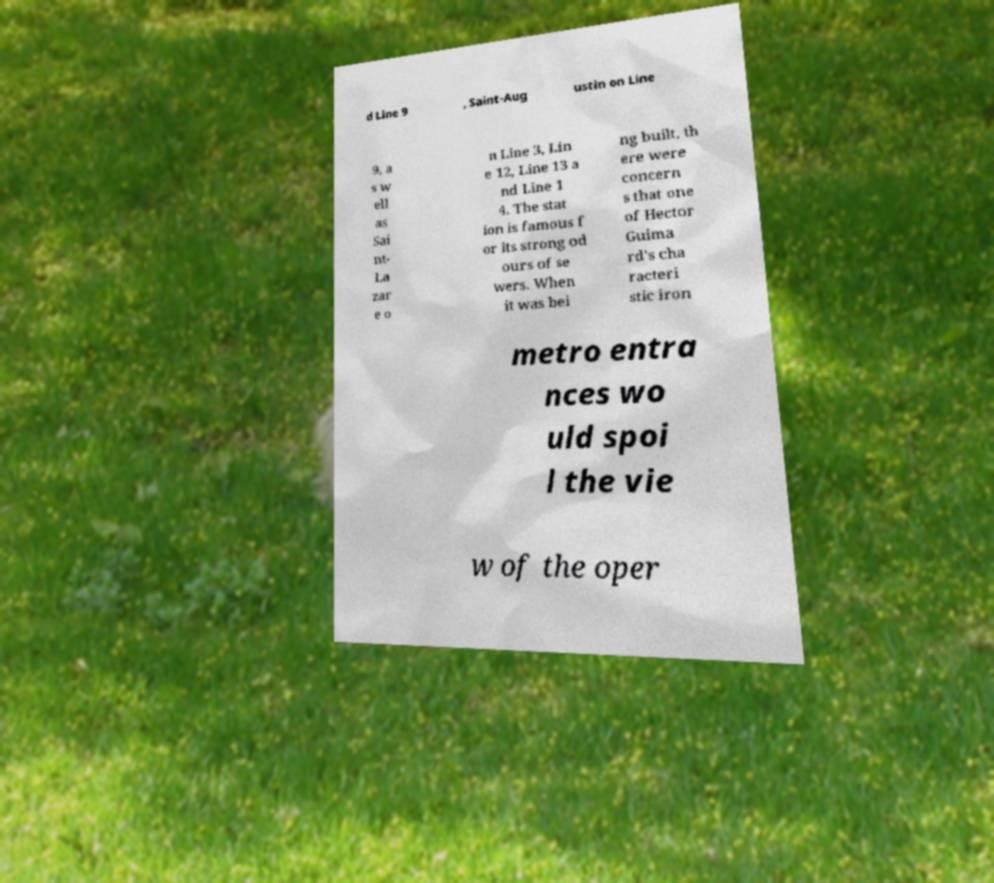I need the written content from this picture converted into text. Can you do that? d Line 9 , Saint-Aug ustin on Line 9, a s w ell as Sai nt- La zar e o n Line 3, Lin e 12, Line 13 a nd Line 1 4. The stat ion is famous f or its strong od ours of se wers. When it was bei ng built, th ere were concern s that one of Hector Guima rd's cha racteri stic iron metro entra nces wo uld spoi l the vie w of the oper 